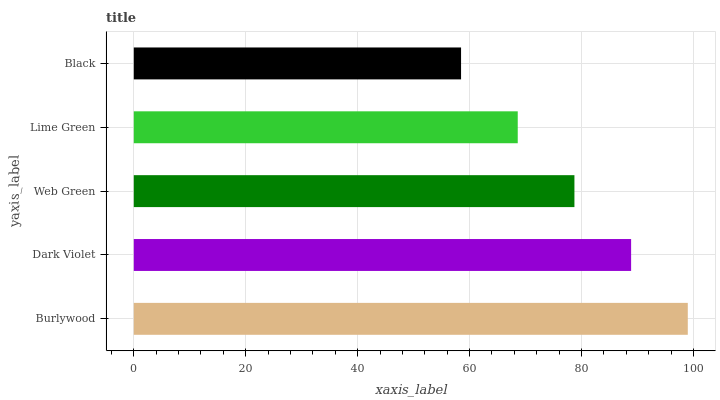Is Black the minimum?
Answer yes or no. Yes. Is Burlywood the maximum?
Answer yes or no. Yes. Is Dark Violet the minimum?
Answer yes or no. No. Is Dark Violet the maximum?
Answer yes or no. No. Is Burlywood greater than Dark Violet?
Answer yes or no. Yes. Is Dark Violet less than Burlywood?
Answer yes or no. Yes. Is Dark Violet greater than Burlywood?
Answer yes or no. No. Is Burlywood less than Dark Violet?
Answer yes or no. No. Is Web Green the high median?
Answer yes or no. Yes. Is Web Green the low median?
Answer yes or no. Yes. Is Dark Violet the high median?
Answer yes or no. No. Is Dark Violet the low median?
Answer yes or no. No. 